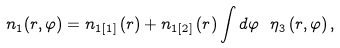<formula> <loc_0><loc_0><loc_500><loc_500>n _ { 1 } ( r , \varphi ) = n _ { 1 [ 1 ] } \left ( r \right ) + n _ { 1 [ 2 ] } \left ( r \right ) \int d \varphi \ \eta _ { 3 } \left ( r , \varphi \right ) ,</formula> 